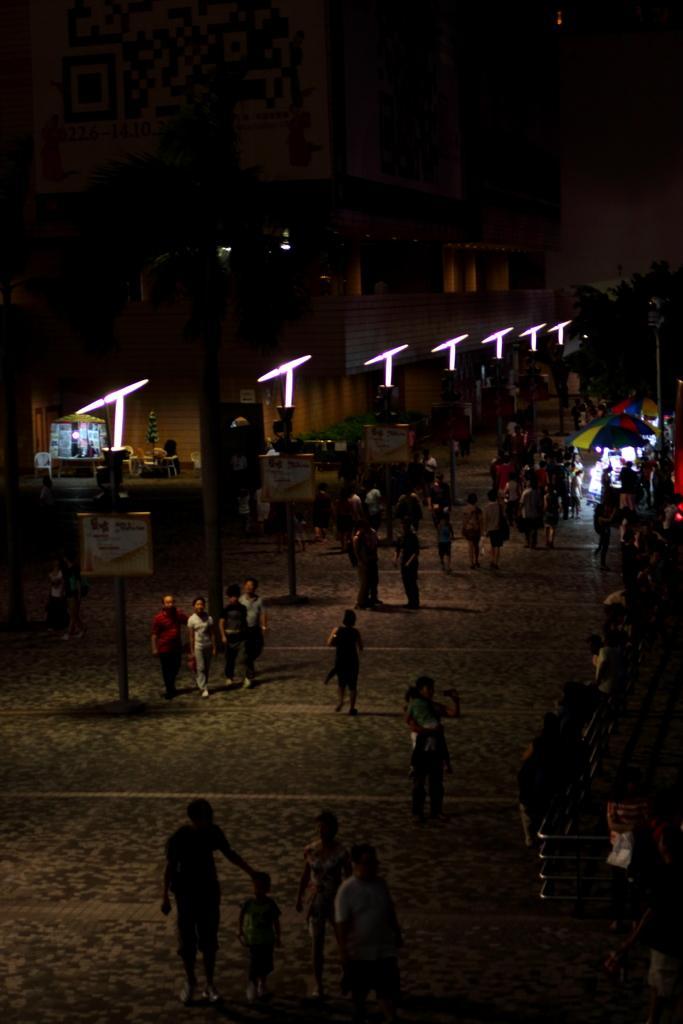Describe this image in one or two sentences. In this image there are people walking on a pavement, in the background there are buildings and lights. 